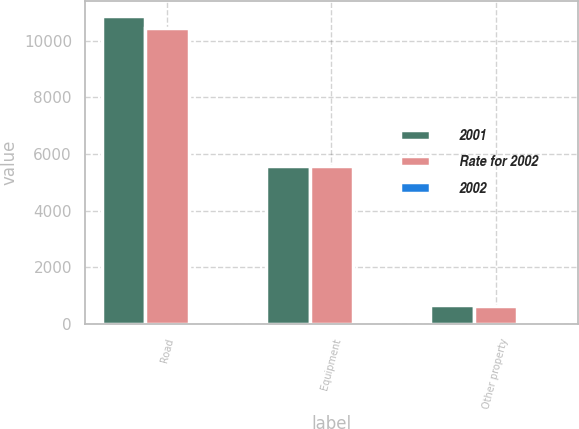Convert chart. <chart><loc_0><loc_0><loc_500><loc_500><stacked_bar_chart><ecel><fcel>Road<fcel>Equipment<fcel>Other property<nl><fcel>2001<fcel>10859<fcel>5573<fcel>655<nl><fcel>Rate for 2002<fcel>10452<fcel>5559<fcel>632<nl><fcel>2002<fcel>2.9<fcel>3.9<fcel>3.1<nl></chart> 